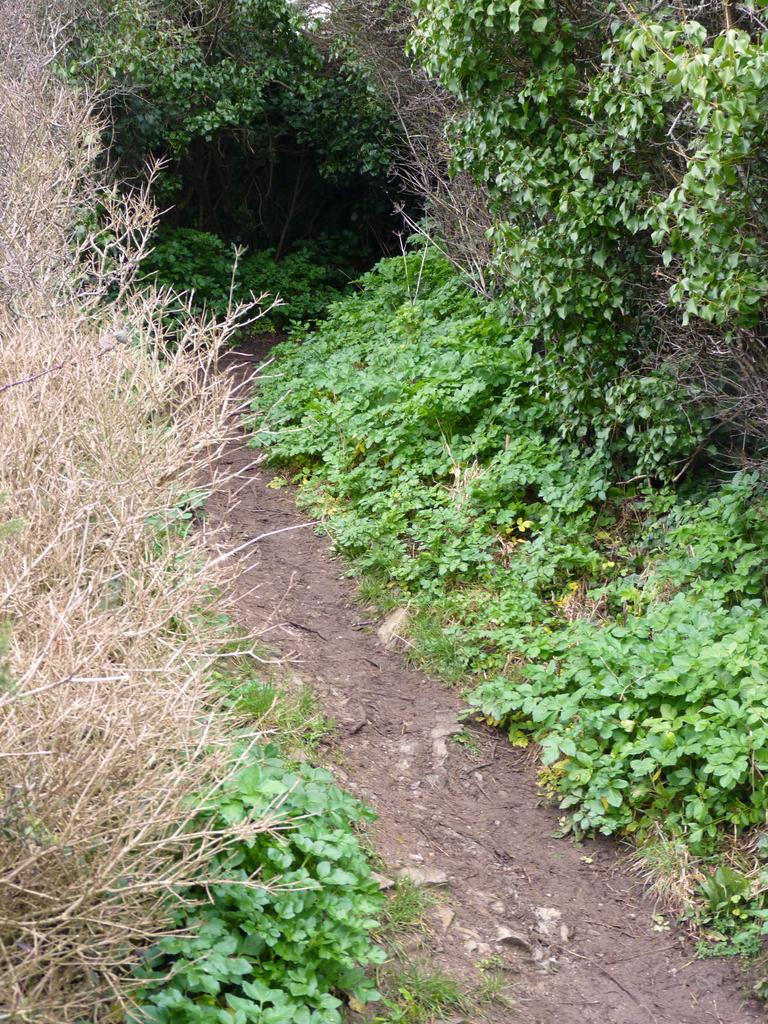Where is the image taken? The image is taken in a small street. What can be seen on the left side of the street? There are shrubs, plants, and trees on the left side of the street. What can be seen on the right side of the street? There are shrubs and trees on the right side of the street. What is in the center of the street? There is a path in the center of the street. How many rings are visible on the boy's finger in the image? There is no boy present in the image, and therefore no rings to count. 